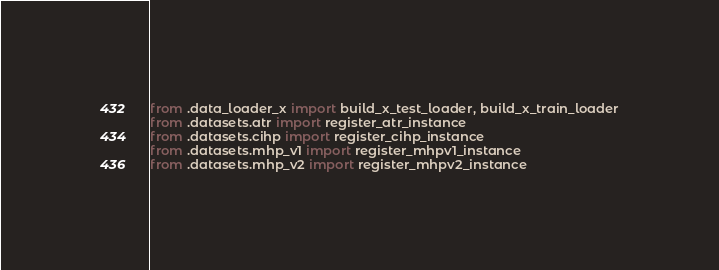<code> <loc_0><loc_0><loc_500><loc_500><_Python_>from .data_loader_x import build_x_test_loader, build_x_train_loader
from .datasets.atr import register_atr_instance
from .datasets.cihp import register_cihp_instance
from .datasets.mhp_v1 import register_mhpv1_instance
from .datasets.mhp_v2 import register_mhpv2_instance
</code> 